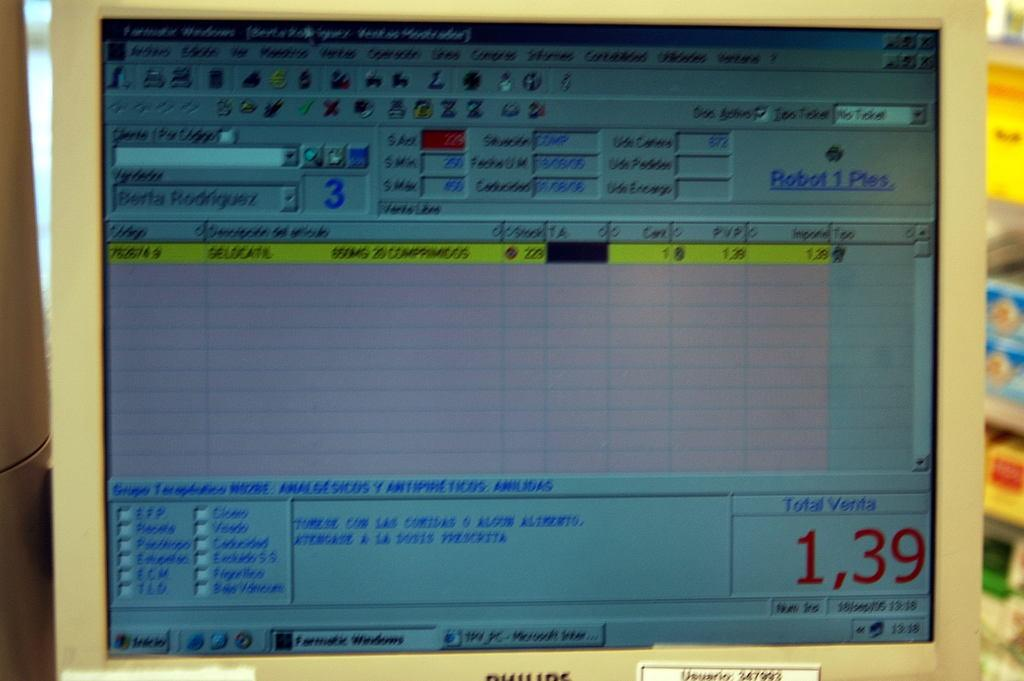<image>
Offer a succinct explanation of the picture presented. a computer screen showing a total of 1,39 is blurry 